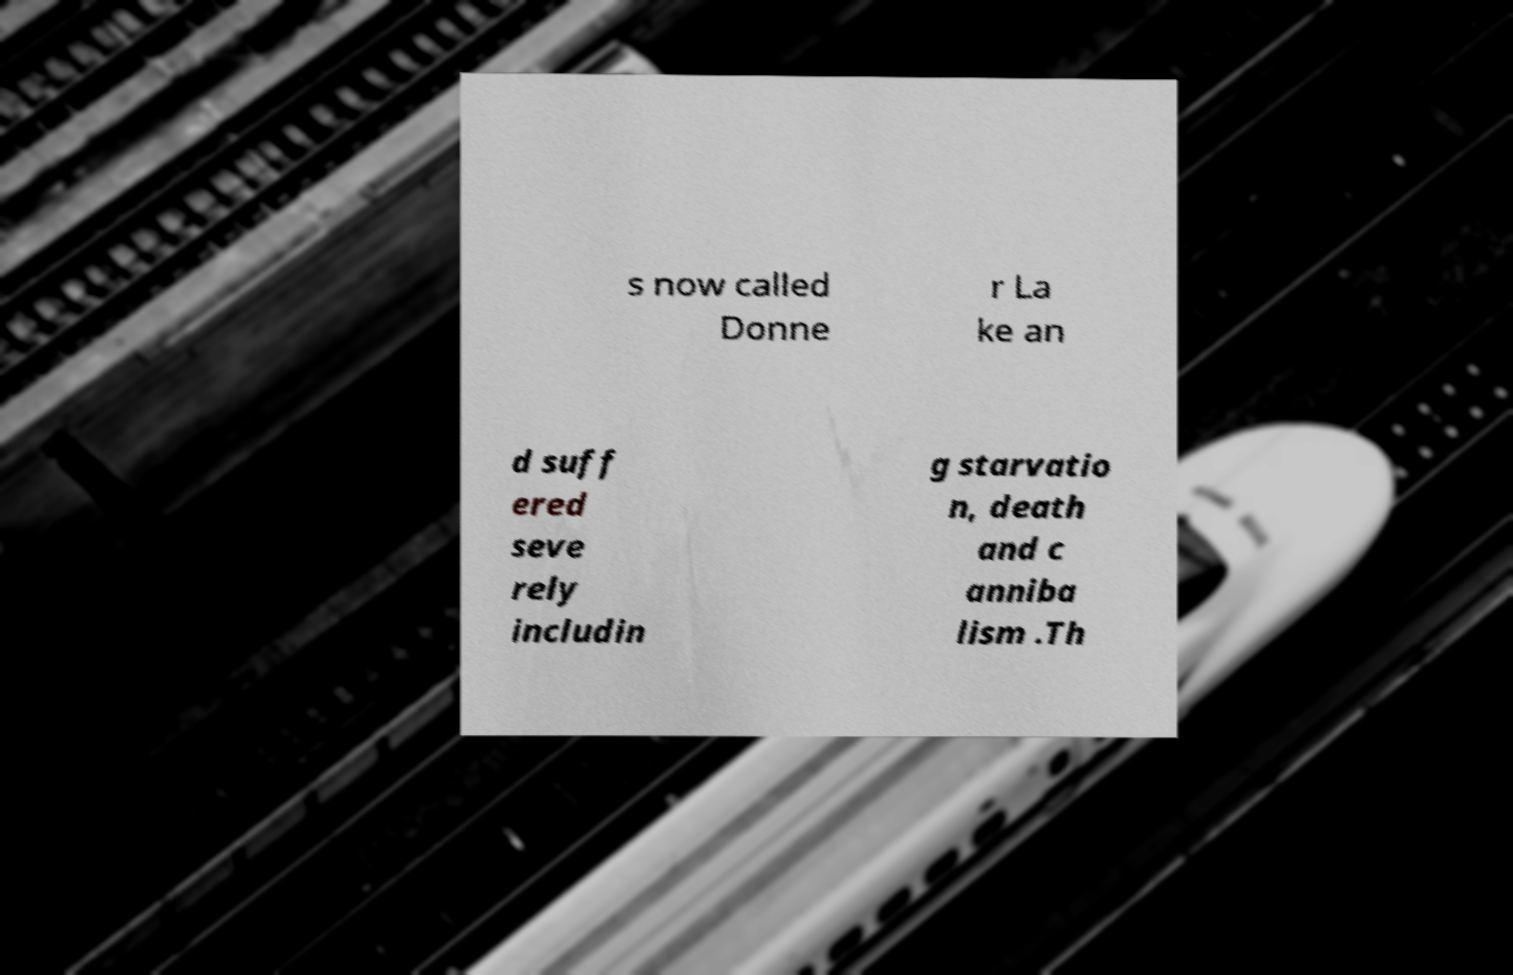I need the written content from this picture converted into text. Can you do that? s now called Donne r La ke an d suff ered seve rely includin g starvatio n, death and c anniba lism .Th 